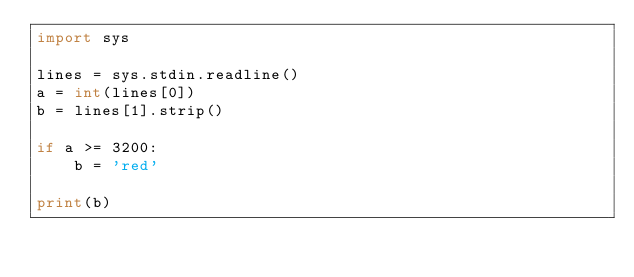<code> <loc_0><loc_0><loc_500><loc_500><_Python_>import sys

lines = sys.stdin.readline()
a = int(lines[0])
b = lines[1].strip()

if a >= 3200:
    b = 'red'

print(b)</code> 